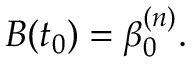Convert formula to latex. <formula><loc_0><loc_0><loc_500><loc_500>B ( t _ { 0 } ) = \beta _ { 0 } ^ { ( n ) } .</formula> 